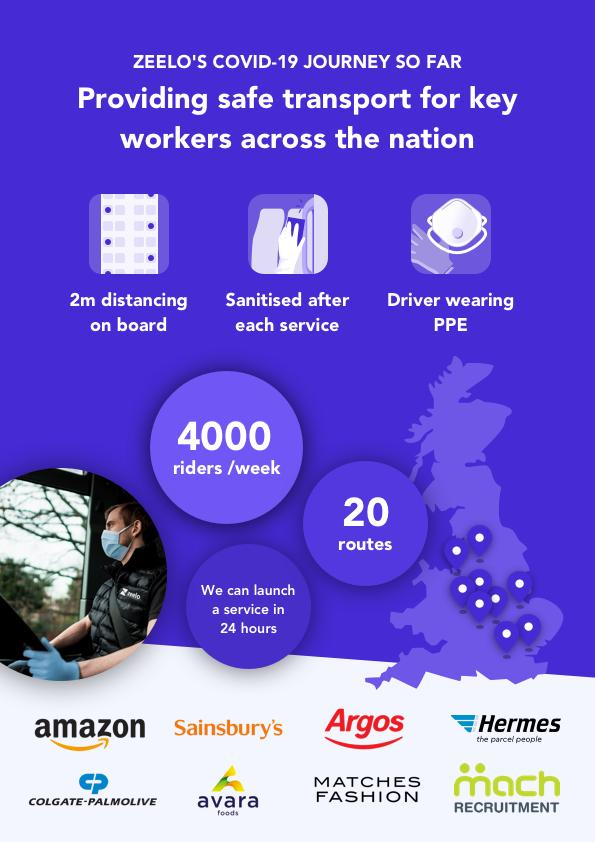List a handful of essential elements in this visual. Zeelo provides transport services for 8 companies. 